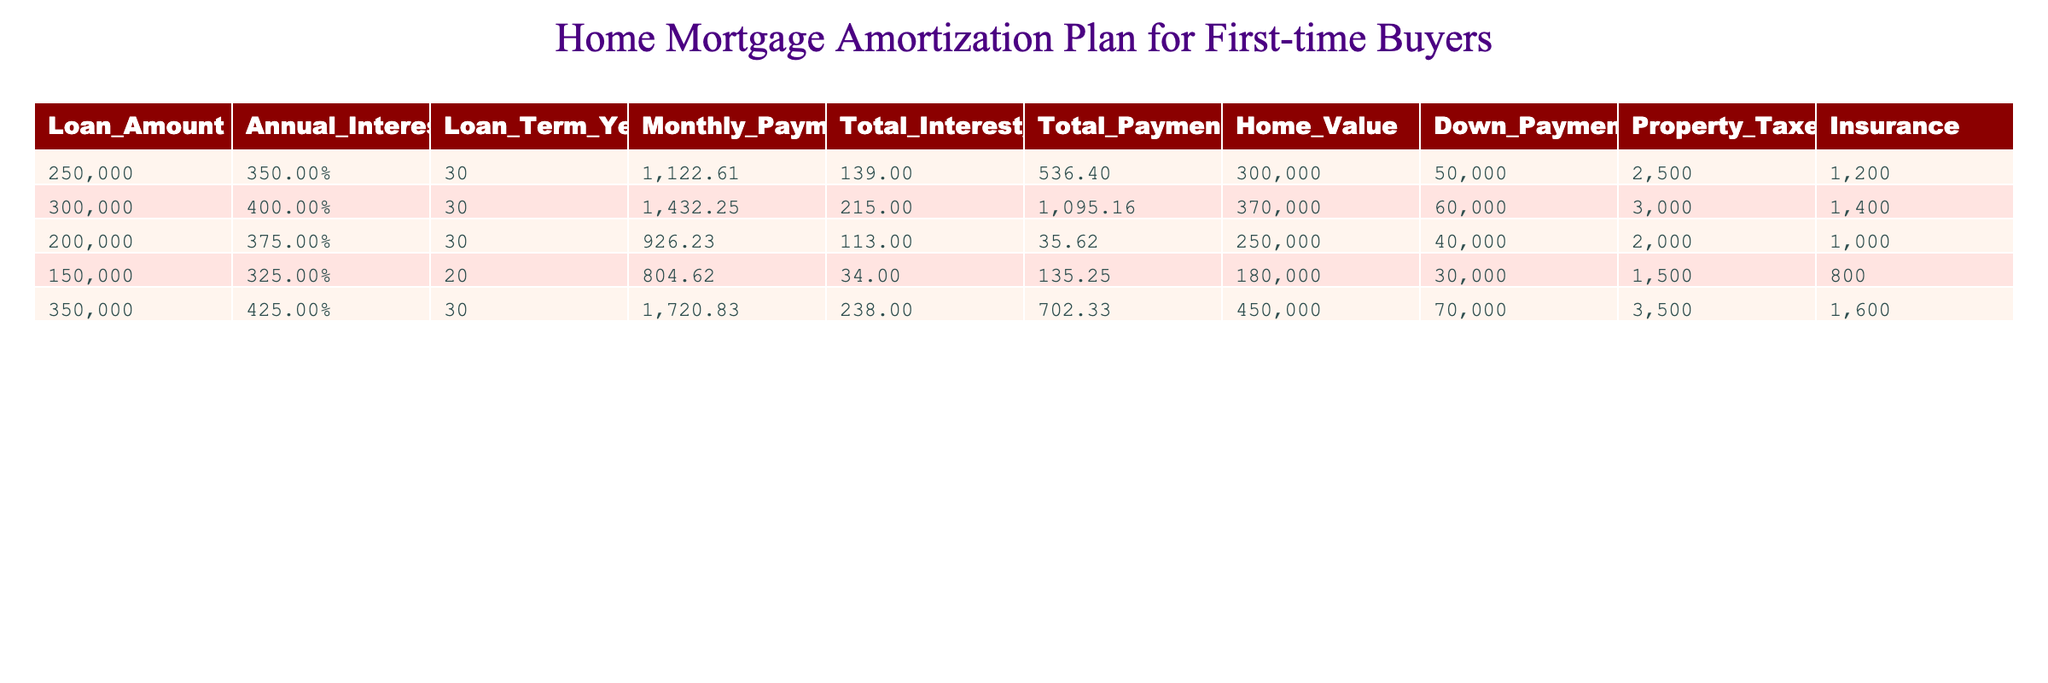What is the monthly payment for a loan of 250,000 at an interest rate of 3.5% over 30 years? The table indicates that for a loan amount of 250,000 with an annual interest rate of 3.5% and a term of 30 years, the monthly payment is listed directly in the corresponding row.
Answer: 1122.61 What is the total interest paid on a loan of 300,000 at an annual interest rate of 4.0%? Referring to the row associated with the loan amount of 300,000 at an interest rate of 4.0%, the total interest paid is taken directly from the table.
Answer: 215,109.16 Which loan has the lowest monthly payment? To find the loan with the lowest monthly payment, we need to compare the monthly payments of all loans in the table: 1122.61, 1432.25, 926.23, 804.62, and 1720.83. The lowest amount is 804.62 from the loan of 150,000 at 3.25% over 20 years.
Answer: 804.62 Is the total payment for the loan of 200,000 more than 300,000? From the table, the total payment for the loan of 200,000 is shown to be 113,035.62, while 300,000 is larger than 215,1095.16. Therefore, the total payment for 200,000 is less than 300,000.
Answer: No If two loans of 250,000 and 200,000 are combined, what will the total payment be? The total payment for the loan of 250,000 is 139,536.40, and for the 200,000 loan, it is 113,035.62. Adding these two values together: 139,536.40 + 113,035.62 = 252,572.02.
Answer: 252,572.02 